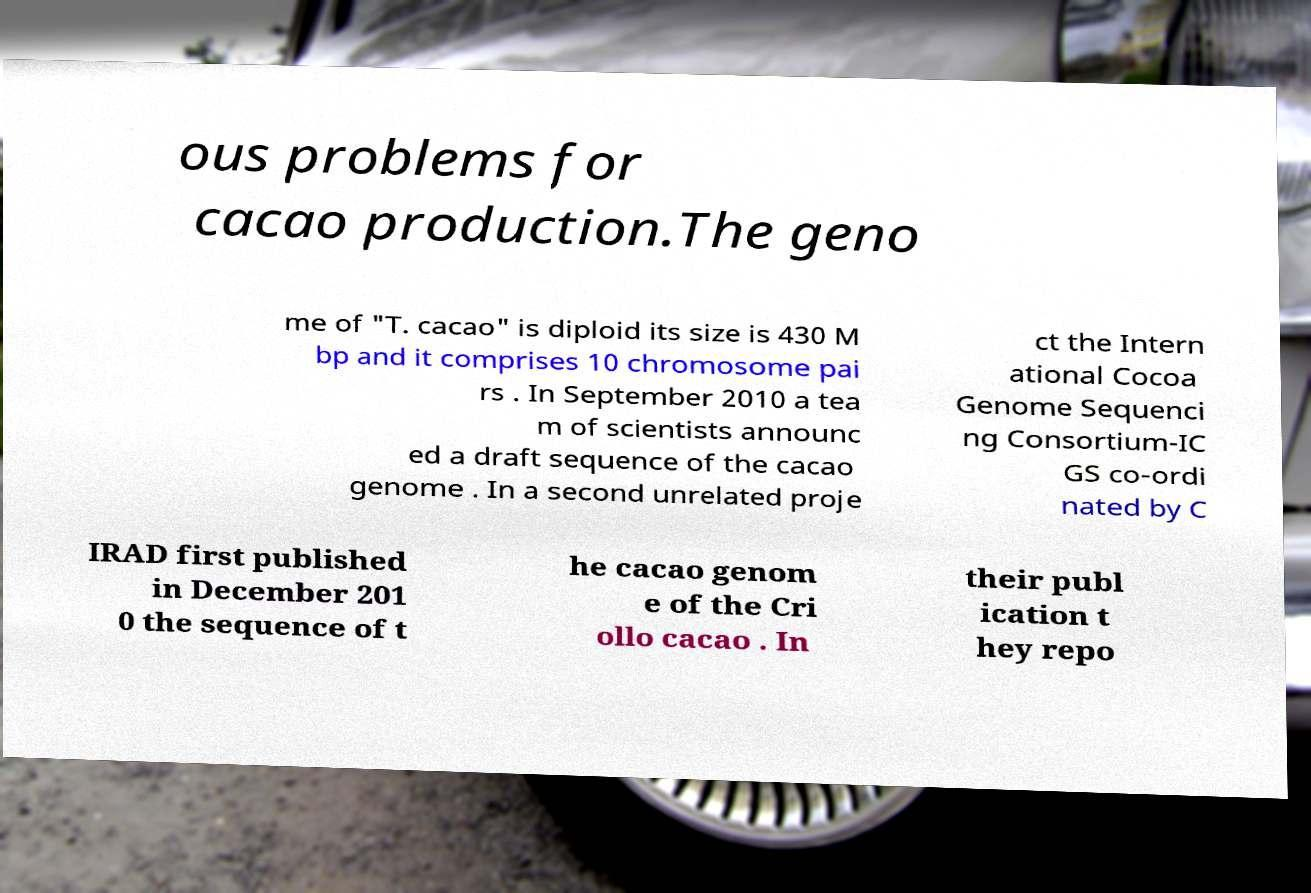There's text embedded in this image that I need extracted. Can you transcribe it verbatim? ous problems for cacao production.The geno me of "T. cacao" is diploid its size is 430 M bp and it comprises 10 chromosome pai rs . In September 2010 a tea m of scientists announc ed a draft sequence of the cacao genome . In a second unrelated proje ct the Intern ational Cocoa Genome Sequenci ng Consortium-IC GS co-ordi nated by C IRAD first published in December 201 0 the sequence of t he cacao genom e of the Cri ollo cacao . In their publ ication t hey repo 